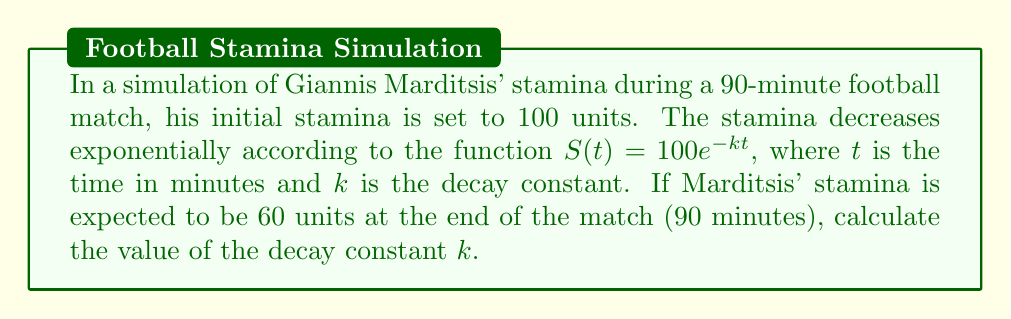Could you help me with this problem? To solve this problem, we'll follow these steps:

1) We're given the stamina function: $S(t) = 100e^{-kt}$

2) We know that at the end of the match (t = 90 minutes), the stamina should be 60 units. Let's substitute these values:

   $60 = 100e^{-k(90)}$

3) Divide both sides by 100:

   $0.6 = e^{-90k}$

4) Take the natural logarithm of both sides:

   $\ln(0.6) = -90k$

5) Solve for k:

   $k = -\frac{\ln(0.6)}{90}$

6) Calculate the value:

   $k = -\frac{\ln(0.6)}{90} \approx 0.005698$

Therefore, the decay constant $k$ is approximately 0.005698 per minute.
Answer: $k \approx 0.005698$ per minute 